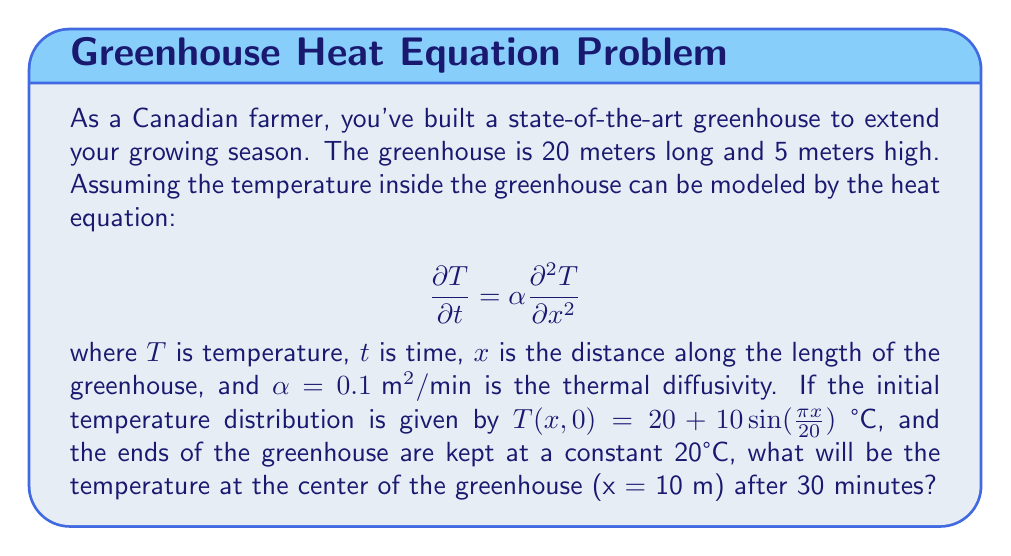Help me with this question. To solve this problem, we need to use the method of separation of variables for the heat equation with given initial and boundary conditions.

1) The heat equation is:
   $$\frac{\partial T}{\partial t} = \alpha \frac{\partial^2 T}{\partial x^2}$$

2) The initial condition is:
   $$T(x,0) = 20 + 10\sin(\frac{\pi x}{20})$$

3) The boundary conditions are:
   $$T(0,t) = T(20,t) = 20$$

4) We seek a solution of the form:
   $$T(x,t) = (A\cos(\lambda x) + B\sin(\lambda x))e^{-\alpha\lambda^2 t}$$

5) Applying the boundary conditions:
   $$T(0,t) = A = 20$$
   $$T(20,t) = A\cos(20\lambda) + B\sin(20\lambda) = 20$$

6) This gives us $\lambda = \frac{n\pi}{20}$ where n is an integer, and $B = 0$ for $n$ even, $B \neq 0$ for $n$ odd.

7) The general solution is:
   $$T(x,t) = 20 + \sum_{n=1}^{\infty} B_n \sin(\frac{n\pi x}{20})e^{-\alpha(\frac{n\pi}{20})^2 t}$$

8) Comparing with the initial condition:
   $$10\sin(\frac{\pi x}{20}) = \sum_{n=1}^{\infty} B_n \sin(\frac{n\pi x}{20})$$

9) This gives us $B_1 = 10$ and $B_n = 0$ for $n > 1$

10) Therefore, the solution is:
    $$T(x,t) = 20 + 10\sin(\frac{\pi x}{20})e^{-\alpha(\frac{\pi}{20})^2 t}$$

11) At the center (x = 10 m) after 30 minutes:
    $$T(10,30) = 20 + 10\sin(\frac{\pi 10}{20})e^{-0.1(\frac{\pi}{20})^2 30}$$
    $$= 20 + 10 \cdot 1 \cdot e^{-0.1(\frac{\pi}{20})^2 30}$$
    $$= 20 + 10e^{-0.007363} \approx 29.93 \text{ °C}$$
Answer: 29.93 °C 